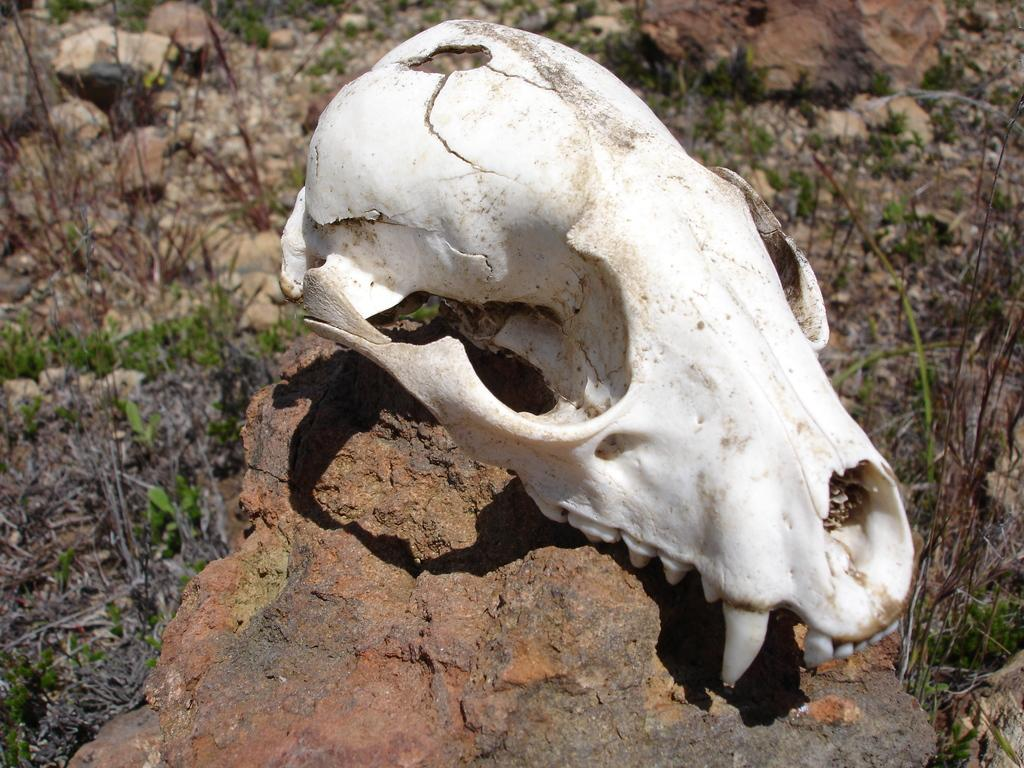What is the main subject of the image? The main subject of the image is a skull of an animal. What is the skull resting on? The skull is on a stone. What can be seen on the ground in the image? The ground is covered with grass and plants. Are there any other stones visible in the image? Yes, there are other stones present in the image. What is the smell of the room in the image? There is no room present in the image, so it is not possible to determine the smell. 